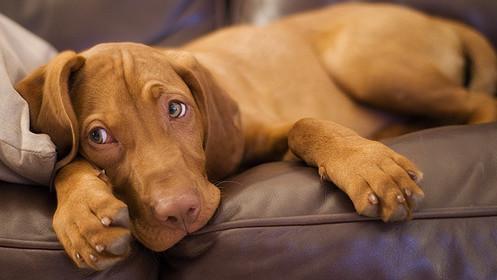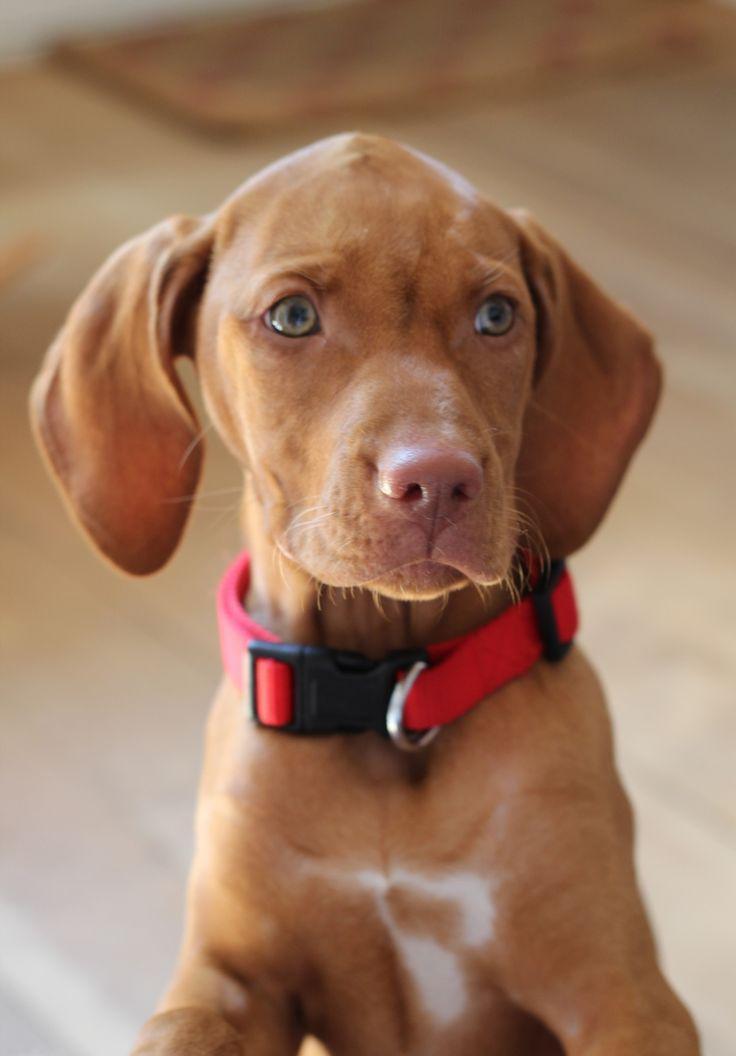The first image is the image on the left, the second image is the image on the right. Considering the images on both sides, is "In at least one image there is a light brown puppy with a red and black collar sitting forward." valid? Answer yes or no. Yes. The first image is the image on the left, the second image is the image on the right. Examine the images to the left and right. Is the description "A dog is wearing a red collar in the right image." accurate? Answer yes or no. Yes. 